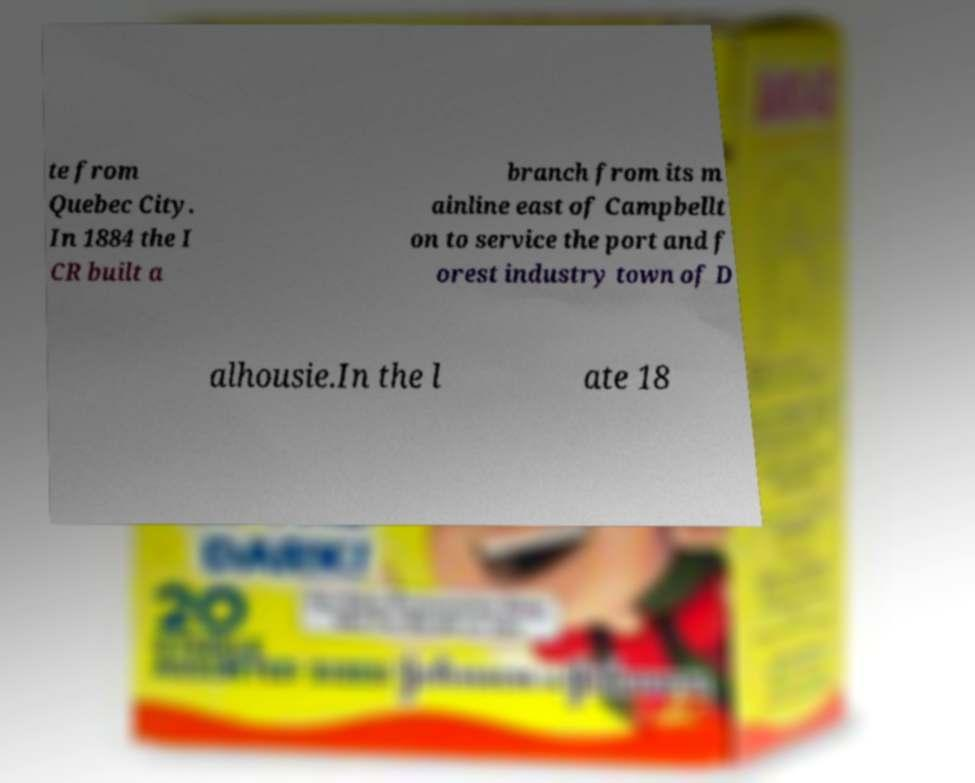For documentation purposes, I need the text within this image transcribed. Could you provide that? te from Quebec City. In 1884 the I CR built a branch from its m ainline east of Campbellt on to service the port and f orest industry town of D alhousie.In the l ate 18 